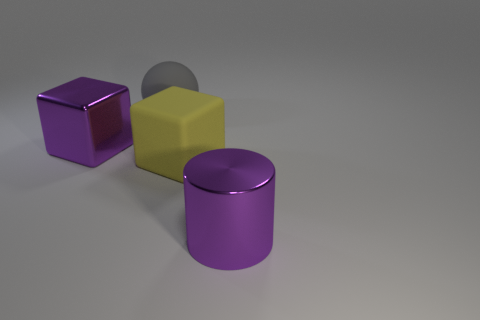Are there an equal number of big rubber blocks to the right of the big yellow thing and big purple metallic blocks left of the purple cube?
Make the answer very short. Yes. Do the rubber object in front of the large purple block and the shiny object to the left of the large purple shiny cylinder have the same color?
Keep it short and to the point. No. Are there more large objects right of the yellow object than cyan blocks?
Provide a succinct answer. Yes. What is the shape of the purple thing that is made of the same material as the purple cylinder?
Keep it short and to the point. Cube. Is the size of the purple object that is right of the gray object the same as the big matte sphere?
Provide a succinct answer. Yes. There is a big purple metallic object that is right of the rubber object that is behind the large yellow rubber thing; what is its shape?
Offer a terse response. Cylinder. What is the size of the purple metallic thing behind the metal thing that is on the right side of the large purple metal block?
Your answer should be compact. Large. The large object that is on the right side of the yellow rubber thing is what color?
Offer a very short reply. Purple. What is the size of the block that is made of the same material as the large gray sphere?
Provide a succinct answer. Large. How many other objects are the same shape as the yellow rubber object?
Your answer should be very brief. 1. 